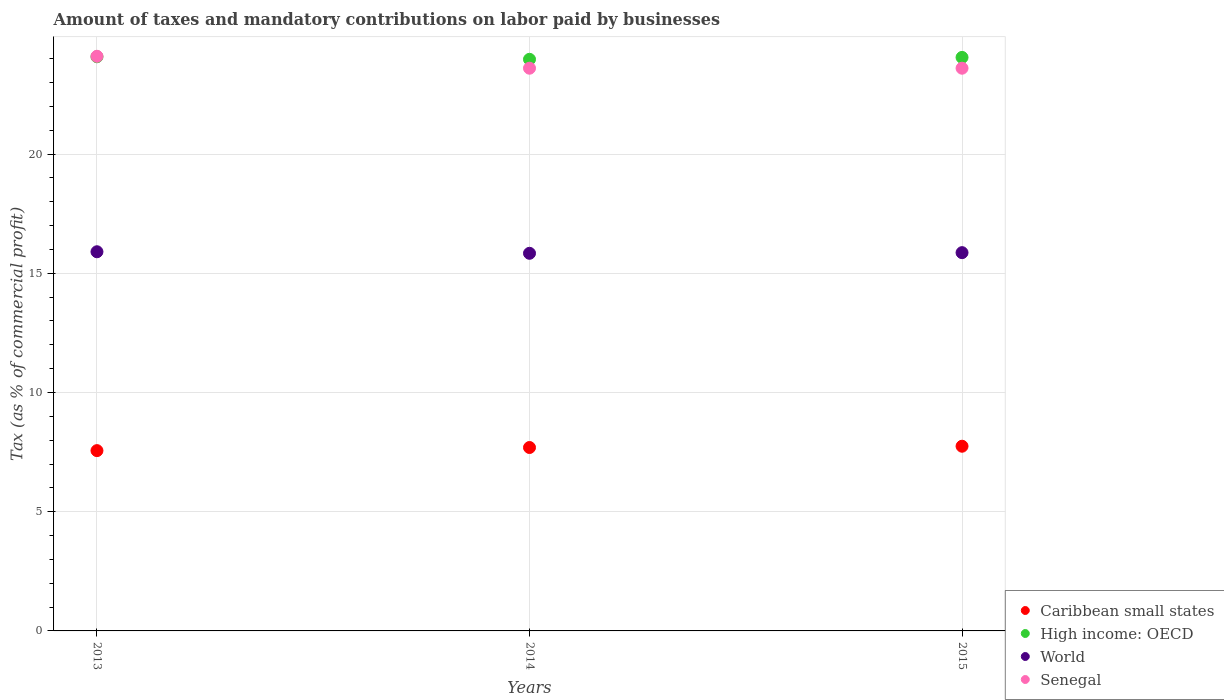How many different coloured dotlines are there?
Give a very brief answer. 4. What is the percentage of taxes paid by businesses in Caribbean small states in 2015?
Make the answer very short. 7.75. Across all years, what is the maximum percentage of taxes paid by businesses in High income: OECD?
Your answer should be very brief. 24.08. Across all years, what is the minimum percentage of taxes paid by businesses in High income: OECD?
Offer a terse response. 23.97. In which year was the percentage of taxes paid by businesses in Caribbean small states maximum?
Offer a terse response. 2015. What is the total percentage of taxes paid by businesses in High income: OECD in the graph?
Offer a terse response. 72.11. What is the difference between the percentage of taxes paid by businesses in World in 2013 and that in 2014?
Offer a terse response. 0.06. What is the difference between the percentage of taxes paid by businesses in Caribbean small states in 2015 and the percentage of taxes paid by businesses in Senegal in 2014?
Offer a terse response. -15.85. What is the average percentage of taxes paid by businesses in Caribbean small states per year?
Keep it short and to the point. 7.67. In the year 2013, what is the difference between the percentage of taxes paid by businesses in High income: OECD and percentage of taxes paid by businesses in Caribbean small states?
Keep it short and to the point. 16.52. What is the ratio of the percentage of taxes paid by businesses in Caribbean small states in 2013 to that in 2014?
Your answer should be compact. 0.98. Is the percentage of taxes paid by businesses in Caribbean small states in 2013 less than that in 2015?
Make the answer very short. Yes. Is the difference between the percentage of taxes paid by businesses in High income: OECD in 2014 and 2015 greater than the difference between the percentage of taxes paid by businesses in Caribbean small states in 2014 and 2015?
Your answer should be very brief. No. What is the difference between the highest and the second highest percentage of taxes paid by businesses in Caribbean small states?
Provide a short and direct response. 0.05. What is the difference between the highest and the lowest percentage of taxes paid by businesses in High income: OECD?
Provide a short and direct response. 0.11. Is the sum of the percentage of taxes paid by businesses in Caribbean small states in 2014 and 2015 greater than the maximum percentage of taxes paid by businesses in Senegal across all years?
Make the answer very short. No. Is it the case that in every year, the sum of the percentage of taxes paid by businesses in Caribbean small states and percentage of taxes paid by businesses in World  is greater than the sum of percentage of taxes paid by businesses in High income: OECD and percentage of taxes paid by businesses in Senegal?
Give a very brief answer. Yes. Is it the case that in every year, the sum of the percentage of taxes paid by businesses in Senegal and percentage of taxes paid by businesses in High income: OECD  is greater than the percentage of taxes paid by businesses in Caribbean small states?
Offer a very short reply. Yes. How many dotlines are there?
Your answer should be compact. 4. What is the difference between two consecutive major ticks on the Y-axis?
Offer a very short reply. 5. Are the values on the major ticks of Y-axis written in scientific E-notation?
Provide a short and direct response. No. Does the graph contain any zero values?
Your answer should be compact. No. Does the graph contain grids?
Offer a very short reply. Yes. How are the legend labels stacked?
Ensure brevity in your answer.  Vertical. What is the title of the graph?
Make the answer very short. Amount of taxes and mandatory contributions on labor paid by businesses. What is the label or title of the Y-axis?
Your answer should be compact. Tax (as % of commercial profit). What is the Tax (as % of commercial profit) in Caribbean small states in 2013?
Offer a terse response. 7.56. What is the Tax (as % of commercial profit) in High income: OECD in 2013?
Offer a terse response. 24.08. What is the Tax (as % of commercial profit) of World in 2013?
Your answer should be compact. 15.9. What is the Tax (as % of commercial profit) in Senegal in 2013?
Your answer should be very brief. 24.1. What is the Tax (as % of commercial profit) of Caribbean small states in 2014?
Provide a short and direct response. 7.69. What is the Tax (as % of commercial profit) in High income: OECD in 2014?
Your answer should be very brief. 23.97. What is the Tax (as % of commercial profit) of World in 2014?
Your answer should be very brief. 15.84. What is the Tax (as % of commercial profit) in Senegal in 2014?
Provide a succinct answer. 23.6. What is the Tax (as % of commercial profit) in Caribbean small states in 2015?
Offer a very short reply. 7.75. What is the Tax (as % of commercial profit) in High income: OECD in 2015?
Your response must be concise. 24.05. What is the Tax (as % of commercial profit) of World in 2015?
Offer a very short reply. 15.86. What is the Tax (as % of commercial profit) of Senegal in 2015?
Your answer should be compact. 23.6. Across all years, what is the maximum Tax (as % of commercial profit) of Caribbean small states?
Offer a very short reply. 7.75. Across all years, what is the maximum Tax (as % of commercial profit) of High income: OECD?
Make the answer very short. 24.08. Across all years, what is the maximum Tax (as % of commercial profit) in World?
Your answer should be compact. 15.9. Across all years, what is the maximum Tax (as % of commercial profit) in Senegal?
Provide a succinct answer. 24.1. Across all years, what is the minimum Tax (as % of commercial profit) in Caribbean small states?
Provide a short and direct response. 7.56. Across all years, what is the minimum Tax (as % of commercial profit) of High income: OECD?
Keep it short and to the point. 23.97. Across all years, what is the minimum Tax (as % of commercial profit) in World?
Offer a very short reply. 15.84. Across all years, what is the minimum Tax (as % of commercial profit) in Senegal?
Provide a short and direct response. 23.6. What is the total Tax (as % of commercial profit) of Caribbean small states in the graph?
Your answer should be very brief. 23. What is the total Tax (as % of commercial profit) of High income: OECD in the graph?
Make the answer very short. 72.11. What is the total Tax (as % of commercial profit) in World in the graph?
Make the answer very short. 47.6. What is the total Tax (as % of commercial profit) of Senegal in the graph?
Keep it short and to the point. 71.3. What is the difference between the Tax (as % of commercial profit) of Caribbean small states in 2013 and that in 2014?
Your answer should be very brief. -0.13. What is the difference between the Tax (as % of commercial profit) in High income: OECD in 2013 and that in 2014?
Your answer should be compact. 0.11. What is the difference between the Tax (as % of commercial profit) of World in 2013 and that in 2014?
Offer a very short reply. 0.06. What is the difference between the Tax (as % of commercial profit) of Caribbean small states in 2013 and that in 2015?
Provide a short and direct response. -0.18. What is the difference between the Tax (as % of commercial profit) of High income: OECD in 2013 and that in 2015?
Give a very brief answer. 0.03. What is the difference between the Tax (as % of commercial profit) in World in 2013 and that in 2015?
Provide a short and direct response. 0.04. What is the difference between the Tax (as % of commercial profit) of Caribbean small states in 2014 and that in 2015?
Your response must be concise. -0.05. What is the difference between the Tax (as % of commercial profit) of High income: OECD in 2014 and that in 2015?
Make the answer very short. -0.08. What is the difference between the Tax (as % of commercial profit) in World in 2014 and that in 2015?
Make the answer very short. -0.03. What is the difference between the Tax (as % of commercial profit) of Caribbean small states in 2013 and the Tax (as % of commercial profit) of High income: OECD in 2014?
Your response must be concise. -16.41. What is the difference between the Tax (as % of commercial profit) in Caribbean small states in 2013 and the Tax (as % of commercial profit) in World in 2014?
Offer a terse response. -8.28. What is the difference between the Tax (as % of commercial profit) of Caribbean small states in 2013 and the Tax (as % of commercial profit) of Senegal in 2014?
Provide a succinct answer. -16.04. What is the difference between the Tax (as % of commercial profit) of High income: OECD in 2013 and the Tax (as % of commercial profit) of World in 2014?
Provide a succinct answer. 8.24. What is the difference between the Tax (as % of commercial profit) of High income: OECD in 2013 and the Tax (as % of commercial profit) of Senegal in 2014?
Provide a short and direct response. 0.48. What is the difference between the Tax (as % of commercial profit) of World in 2013 and the Tax (as % of commercial profit) of Senegal in 2014?
Make the answer very short. -7.7. What is the difference between the Tax (as % of commercial profit) of Caribbean small states in 2013 and the Tax (as % of commercial profit) of High income: OECD in 2015?
Provide a succinct answer. -16.49. What is the difference between the Tax (as % of commercial profit) in Caribbean small states in 2013 and the Tax (as % of commercial profit) in World in 2015?
Provide a succinct answer. -8.3. What is the difference between the Tax (as % of commercial profit) of Caribbean small states in 2013 and the Tax (as % of commercial profit) of Senegal in 2015?
Offer a very short reply. -16.04. What is the difference between the Tax (as % of commercial profit) in High income: OECD in 2013 and the Tax (as % of commercial profit) in World in 2015?
Provide a short and direct response. 8.22. What is the difference between the Tax (as % of commercial profit) of High income: OECD in 2013 and the Tax (as % of commercial profit) of Senegal in 2015?
Offer a very short reply. 0.48. What is the difference between the Tax (as % of commercial profit) in World in 2013 and the Tax (as % of commercial profit) in Senegal in 2015?
Provide a short and direct response. -7.7. What is the difference between the Tax (as % of commercial profit) of Caribbean small states in 2014 and the Tax (as % of commercial profit) of High income: OECD in 2015?
Keep it short and to the point. -16.36. What is the difference between the Tax (as % of commercial profit) in Caribbean small states in 2014 and the Tax (as % of commercial profit) in World in 2015?
Your answer should be compact. -8.17. What is the difference between the Tax (as % of commercial profit) of Caribbean small states in 2014 and the Tax (as % of commercial profit) of Senegal in 2015?
Keep it short and to the point. -15.91. What is the difference between the Tax (as % of commercial profit) of High income: OECD in 2014 and the Tax (as % of commercial profit) of World in 2015?
Make the answer very short. 8.11. What is the difference between the Tax (as % of commercial profit) of High income: OECD in 2014 and the Tax (as % of commercial profit) of Senegal in 2015?
Offer a terse response. 0.37. What is the difference between the Tax (as % of commercial profit) in World in 2014 and the Tax (as % of commercial profit) in Senegal in 2015?
Keep it short and to the point. -7.76. What is the average Tax (as % of commercial profit) of Caribbean small states per year?
Provide a short and direct response. 7.67. What is the average Tax (as % of commercial profit) of High income: OECD per year?
Your answer should be compact. 24.04. What is the average Tax (as % of commercial profit) of World per year?
Your answer should be very brief. 15.87. What is the average Tax (as % of commercial profit) of Senegal per year?
Provide a succinct answer. 23.77. In the year 2013, what is the difference between the Tax (as % of commercial profit) of Caribbean small states and Tax (as % of commercial profit) of High income: OECD?
Your answer should be very brief. -16.52. In the year 2013, what is the difference between the Tax (as % of commercial profit) of Caribbean small states and Tax (as % of commercial profit) of World?
Offer a terse response. -8.34. In the year 2013, what is the difference between the Tax (as % of commercial profit) of Caribbean small states and Tax (as % of commercial profit) of Senegal?
Offer a terse response. -16.54. In the year 2013, what is the difference between the Tax (as % of commercial profit) of High income: OECD and Tax (as % of commercial profit) of World?
Provide a short and direct response. 8.18. In the year 2013, what is the difference between the Tax (as % of commercial profit) in High income: OECD and Tax (as % of commercial profit) in Senegal?
Your response must be concise. -0.02. In the year 2013, what is the difference between the Tax (as % of commercial profit) in World and Tax (as % of commercial profit) in Senegal?
Your response must be concise. -8.2. In the year 2014, what is the difference between the Tax (as % of commercial profit) in Caribbean small states and Tax (as % of commercial profit) in High income: OECD?
Your answer should be very brief. -16.28. In the year 2014, what is the difference between the Tax (as % of commercial profit) in Caribbean small states and Tax (as % of commercial profit) in World?
Your answer should be compact. -8.15. In the year 2014, what is the difference between the Tax (as % of commercial profit) in Caribbean small states and Tax (as % of commercial profit) in Senegal?
Keep it short and to the point. -15.91. In the year 2014, what is the difference between the Tax (as % of commercial profit) in High income: OECD and Tax (as % of commercial profit) in World?
Your answer should be compact. 8.14. In the year 2014, what is the difference between the Tax (as % of commercial profit) of High income: OECD and Tax (as % of commercial profit) of Senegal?
Offer a terse response. 0.37. In the year 2014, what is the difference between the Tax (as % of commercial profit) of World and Tax (as % of commercial profit) of Senegal?
Ensure brevity in your answer.  -7.76. In the year 2015, what is the difference between the Tax (as % of commercial profit) of Caribbean small states and Tax (as % of commercial profit) of High income: OECD?
Offer a terse response. -16.31. In the year 2015, what is the difference between the Tax (as % of commercial profit) in Caribbean small states and Tax (as % of commercial profit) in World?
Provide a succinct answer. -8.12. In the year 2015, what is the difference between the Tax (as % of commercial profit) in Caribbean small states and Tax (as % of commercial profit) in Senegal?
Your answer should be very brief. -15.85. In the year 2015, what is the difference between the Tax (as % of commercial profit) in High income: OECD and Tax (as % of commercial profit) in World?
Provide a succinct answer. 8.19. In the year 2015, what is the difference between the Tax (as % of commercial profit) of High income: OECD and Tax (as % of commercial profit) of Senegal?
Ensure brevity in your answer.  0.45. In the year 2015, what is the difference between the Tax (as % of commercial profit) of World and Tax (as % of commercial profit) of Senegal?
Make the answer very short. -7.74. What is the ratio of the Tax (as % of commercial profit) of High income: OECD in 2013 to that in 2014?
Provide a short and direct response. 1. What is the ratio of the Tax (as % of commercial profit) in World in 2013 to that in 2014?
Ensure brevity in your answer.  1. What is the ratio of the Tax (as % of commercial profit) of Senegal in 2013 to that in 2014?
Ensure brevity in your answer.  1.02. What is the ratio of the Tax (as % of commercial profit) of Caribbean small states in 2013 to that in 2015?
Provide a short and direct response. 0.98. What is the ratio of the Tax (as % of commercial profit) in Senegal in 2013 to that in 2015?
Make the answer very short. 1.02. What is the difference between the highest and the second highest Tax (as % of commercial profit) in Caribbean small states?
Your response must be concise. 0.05. What is the difference between the highest and the second highest Tax (as % of commercial profit) in High income: OECD?
Provide a short and direct response. 0.03. What is the difference between the highest and the second highest Tax (as % of commercial profit) in World?
Offer a terse response. 0.04. What is the difference between the highest and the second highest Tax (as % of commercial profit) in Senegal?
Provide a short and direct response. 0.5. What is the difference between the highest and the lowest Tax (as % of commercial profit) in Caribbean small states?
Your response must be concise. 0.18. What is the difference between the highest and the lowest Tax (as % of commercial profit) of High income: OECD?
Make the answer very short. 0.11. What is the difference between the highest and the lowest Tax (as % of commercial profit) in World?
Offer a terse response. 0.06. What is the difference between the highest and the lowest Tax (as % of commercial profit) of Senegal?
Your answer should be compact. 0.5. 